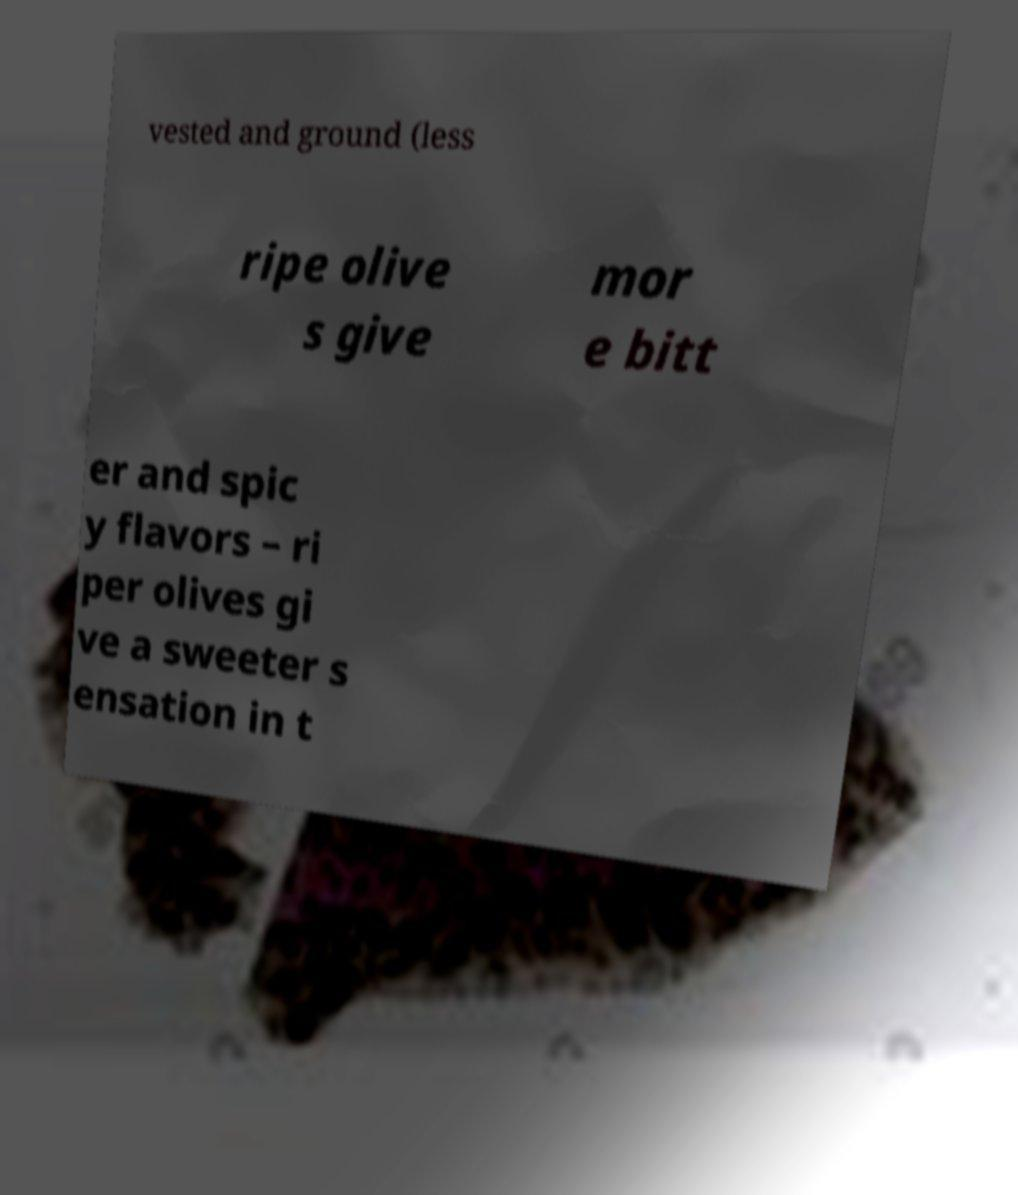There's text embedded in this image that I need extracted. Can you transcribe it verbatim? vested and ground (less ripe olive s give mor e bitt er and spic y flavors – ri per olives gi ve a sweeter s ensation in t 